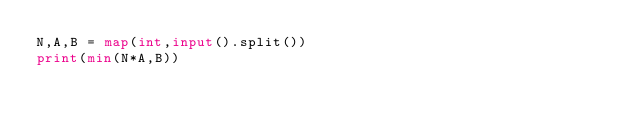<code> <loc_0><loc_0><loc_500><loc_500><_Python_>N,A,B = map(int,input().split())
print(min(N*A,B))</code> 